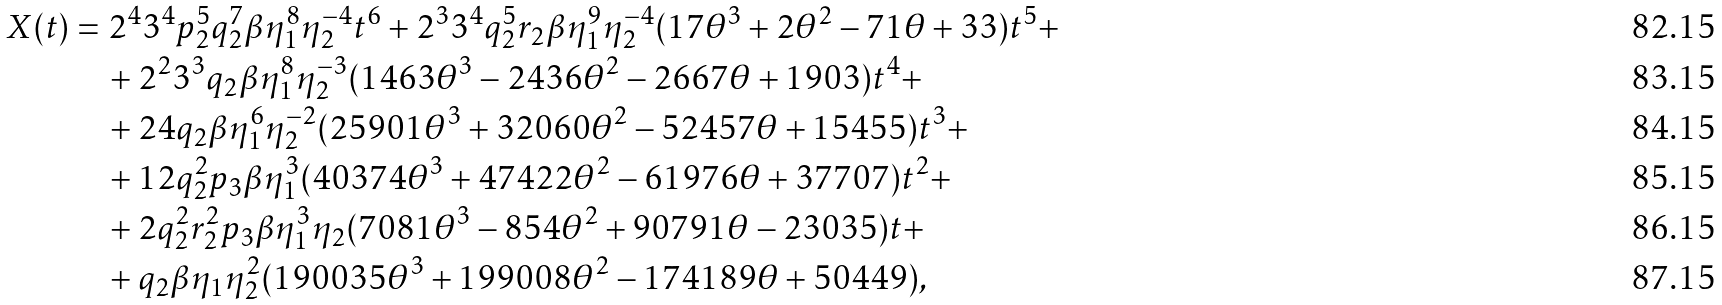Convert formula to latex. <formula><loc_0><loc_0><loc_500><loc_500>X ( t ) & = 2 ^ { 4 } 3 ^ { 4 } p _ { 2 } ^ { 5 } q _ { 2 } ^ { 7 } \beta \eta _ { 1 } ^ { 8 } \eta _ { 2 } ^ { - 4 } t ^ { 6 } + 2 ^ { 3 } 3 ^ { 4 } q _ { 2 } ^ { 5 } r _ { 2 } \beta \eta _ { 1 } ^ { 9 } \eta _ { 2 } ^ { - 4 } ( 1 7 \theta ^ { 3 } + 2 \theta ^ { 2 } - 7 1 \theta + 3 3 ) t ^ { 5 } + \\ & \quad + 2 ^ { 2 } 3 ^ { 3 } q _ { 2 } \beta \eta _ { 1 } ^ { 8 } \eta _ { 2 } ^ { - 3 } ( 1 4 6 3 \theta ^ { 3 } - 2 4 3 6 \theta ^ { 2 } - 2 6 6 7 \theta + 1 9 0 3 ) t ^ { 4 } + \\ & \quad + 2 4 q _ { 2 } \beta \eta _ { 1 } ^ { 6 } \eta _ { 2 } ^ { - 2 } ( 2 5 9 0 1 \theta ^ { 3 } + 3 2 0 6 0 \theta ^ { 2 } - 5 2 4 5 7 \theta + 1 5 4 5 5 ) t ^ { 3 } + \\ & \quad + 1 2 q _ { 2 } ^ { 2 } p _ { 3 } \beta \eta _ { 1 } ^ { 3 } ( 4 0 3 7 4 \theta ^ { 3 } + 4 7 4 2 2 \theta ^ { 2 } - 6 1 9 7 6 \theta + 3 7 7 0 7 ) t ^ { 2 } + \\ & \quad + 2 q _ { 2 } ^ { 2 } r _ { 2 } ^ { 2 } p _ { 3 } \beta \eta _ { 1 } ^ { 3 } \eta _ { 2 } ( 7 0 8 1 \theta ^ { 3 } - 8 5 4 \theta ^ { 2 } + 9 0 7 9 1 \theta - 2 3 0 3 5 ) t + \\ & \quad + q _ { 2 } \beta \eta _ { 1 } \eta _ { 2 } ^ { 2 } ( 1 9 0 0 3 5 \theta ^ { 3 } + 1 9 9 0 0 8 \theta ^ { 2 } - 1 7 4 1 8 9 \theta + 5 0 4 4 9 ) ,</formula> 